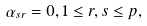<formula> <loc_0><loc_0><loc_500><loc_500>\alpha _ { s r } = 0 , 1 \leq r , s \leq p ,</formula> 